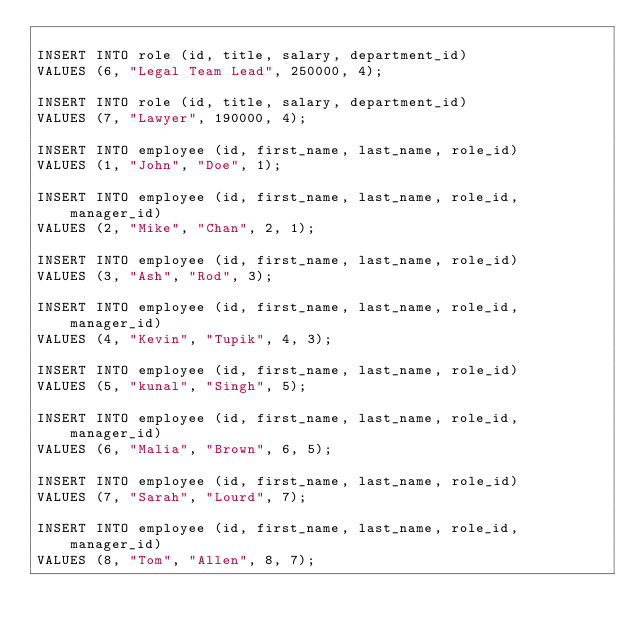Convert code to text. <code><loc_0><loc_0><loc_500><loc_500><_SQL_>
INSERT INTO role (id, title, salary, department_id)
VALUES (6, "Legal Team Lead", 250000, 4);

INSERT INTO role (id, title, salary, department_id)
VALUES (7, "Lawyer", 190000, 4);

INSERT INTO employee (id, first_name, last_name, role_id)
VALUES (1, "John", "Doe", 1);

INSERT INTO employee (id, first_name, last_name, role_id, manager_id)
VALUES (2, "Mike", "Chan", 2, 1);

INSERT INTO employee (id, first_name, last_name, role_id)
VALUES (3, "Ash", "Rod", 3);

INSERT INTO employee (id, first_name, last_name, role_id, manager_id)
VALUES (4, "Kevin", "Tupik", 4, 3);

INSERT INTO employee (id, first_name, last_name, role_id)
VALUES (5, "kunal", "Singh", 5);

INSERT INTO employee (id, first_name, last_name, role_id, manager_id)
VALUES (6, "Malia", "Brown", 6, 5);

INSERT INTO employee (id, first_name, last_name, role_id)
VALUES (7, "Sarah", "Lourd", 7);

INSERT INTO employee (id, first_name, last_name, role_id, manager_id)
VALUES (8, "Tom", "Allen", 8, 7);</code> 